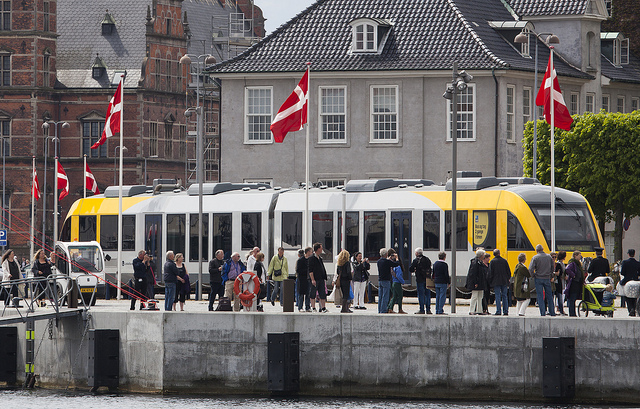<image>What color are the wheels on the carriage? There are no wheels on the carriage in the image. However, usually, the wheels on a carriage are black. What country is it? I am not sure which country it is. It could be Britain, England, Denmark, London, Canada, France, Switzerland, or China. What color are the wheels on the carriage? The wheels on the carriage are black. What country is it? I don't know what country it is. It can be Britain, England, Denmark, London, Canada, France, Switzerland, or China. 